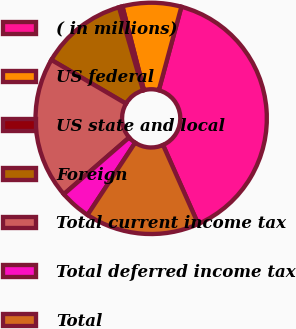Convert chart. <chart><loc_0><loc_0><loc_500><loc_500><pie_chart><fcel>( in millions)<fcel>US federal<fcel>US state and local<fcel>Foreign<fcel>Total current income tax<fcel>Total deferred income tax<fcel>Total<nl><fcel>39.13%<fcel>8.21%<fcel>0.49%<fcel>12.08%<fcel>19.81%<fcel>4.35%<fcel>15.94%<nl></chart> 